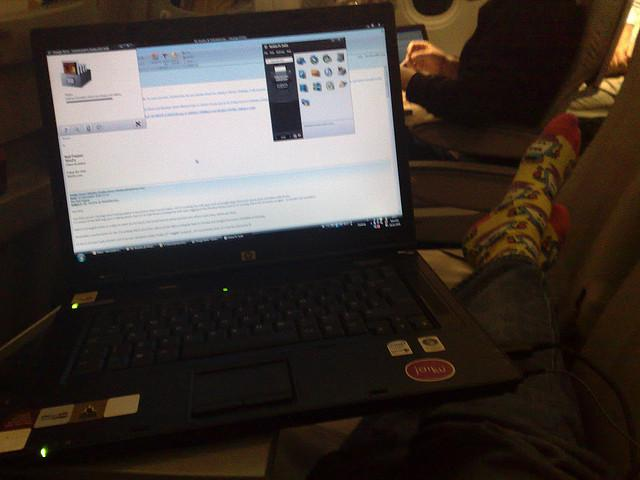This person is operating their laptop in what form of transportation? Please explain your reasoning. plane. The laptop is in plane mode for the wifi. 